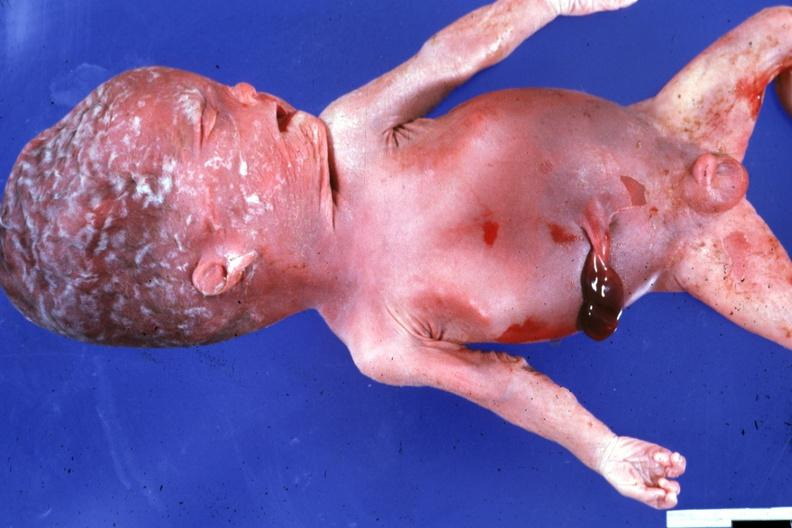does this image show typical not advanced macerated stillborn?
Answer the question using a single word or phrase. Yes 